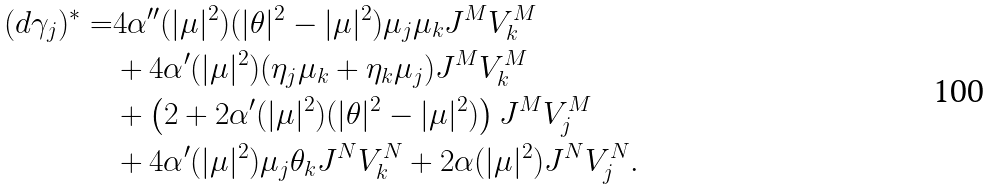Convert formula to latex. <formula><loc_0><loc_0><loc_500><loc_500>( d \gamma _ { j } ) ^ { * } = & 4 \alpha ^ { \prime \prime } ( | \mu | ^ { 2 } ) ( | \theta | ^ { 2 } - | \mu | ^ { 2 } ) \mu _ { j } \mu _ { k } J ^ { M } V _ { k } ^ { M } \\ & + 4 \alpha ^ { \prime } ( | \mu | ^ { 2 } ) ( \eta _ { j } \mu _ { k } + \eta _ { k } \mu _ { j } ) J ^ { M } V _ { k } ^ { M } \\ & + \left ( 2 + 2 \alpha ^ { \prime } ( | \mu | ^ { 2 } ) ( | \theta | ^ { 2 } - | \mu | ^ { 2 } ) \right ) J ^ { M } V _ { j } ^ { M } \\ & + 4 \alpha ^ { \prime } ( | \mu | ^ { 2 } ) \mu _ { j } \theta _ { k } J ^ { N } V _ { k } ^ { N } + 2 \alpha ( | \mu | ^ { 2 } ) J ^ { N } V _ { j } ^ { N } .</formula> 